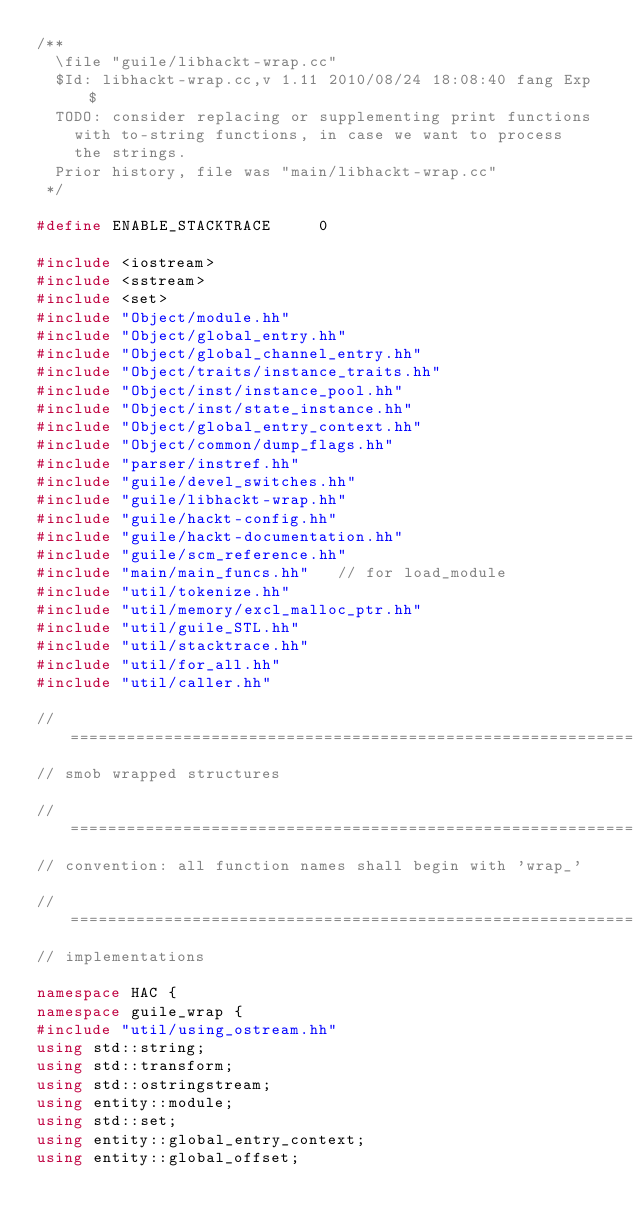<code> <loc_0><loc_0><loc_500><loc_500><_C++_>/**
	\file "guile/libhackt-wrap.cc"
	$Id: libhackt-wrap.cc,v 1.11 2010/08/24 18:08:40 fang Exp $
	TODO: consider replacing or supplementing print functions 
		with to-string functions, in case we want to process 
		the strings.
	Prior history, file was "main/libhackt-wrap.cc"
 */

#define	ENABLE_STACKTRACE			0

#include <iostream>
#include <sstream>
#include <set>
#include "Object/module.hh"
#include "Object/global_entry.hh"
#include "Object/global_channel_entry.hh"
#include "Object/traits/instance_traits.hh"
#include "Object/inst/instance_pool.hh"
#include "Object/inst/state_instance.hh"
#include "Object/global_entry_context.hh"
#include "Object/common/dump_flags.hh"
#include "parser/instref.hh"
#include "guile/devel_switches.hh"
#include "guile/libhackt-wrap.hh"
#include "guile/hackt-config.hh"
#include "guile/hackt-documentation.hh"
#include "guile/scm_reference.hh"
#include "main/main_funcs.hh"		// for load_module
#include "util/tokenize.hh"
#include "util/memory/excl_malloc_ptr.hh"
#include "util/guile_STL.hh"
#include "util/stacktrace.hh"
#include "util/for_all.hh"
#include "util/caller.hh"

//=============================================================================
// smob wrapped structures

//=============================================================================
// convention: all function names shall begin with 'wrap_'

//=============================================================================
// implementations

namespace HAC {
namespace guile_wrap {
#include "util/using_ostream.hh"
using std::string;
using std::transform;
using std::ostringstream;
using entity::module;
using std::set;
using entity::global_entry_context;
using entity::global_offset;</code> 